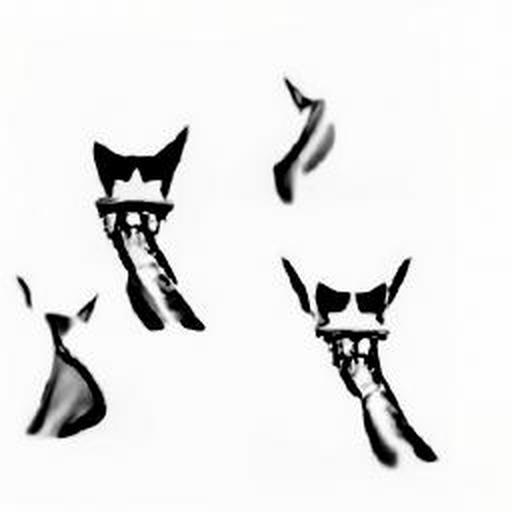What artistic technique might have been used to create this blurry effect? The blurry effect in the image may have been achieved using selective focus, where the camera lens is adjusted to focus on a specific plane, causing other elements to become softly out of focus. It's a common technique in photography to isolate subjects and create a sense of depth. 